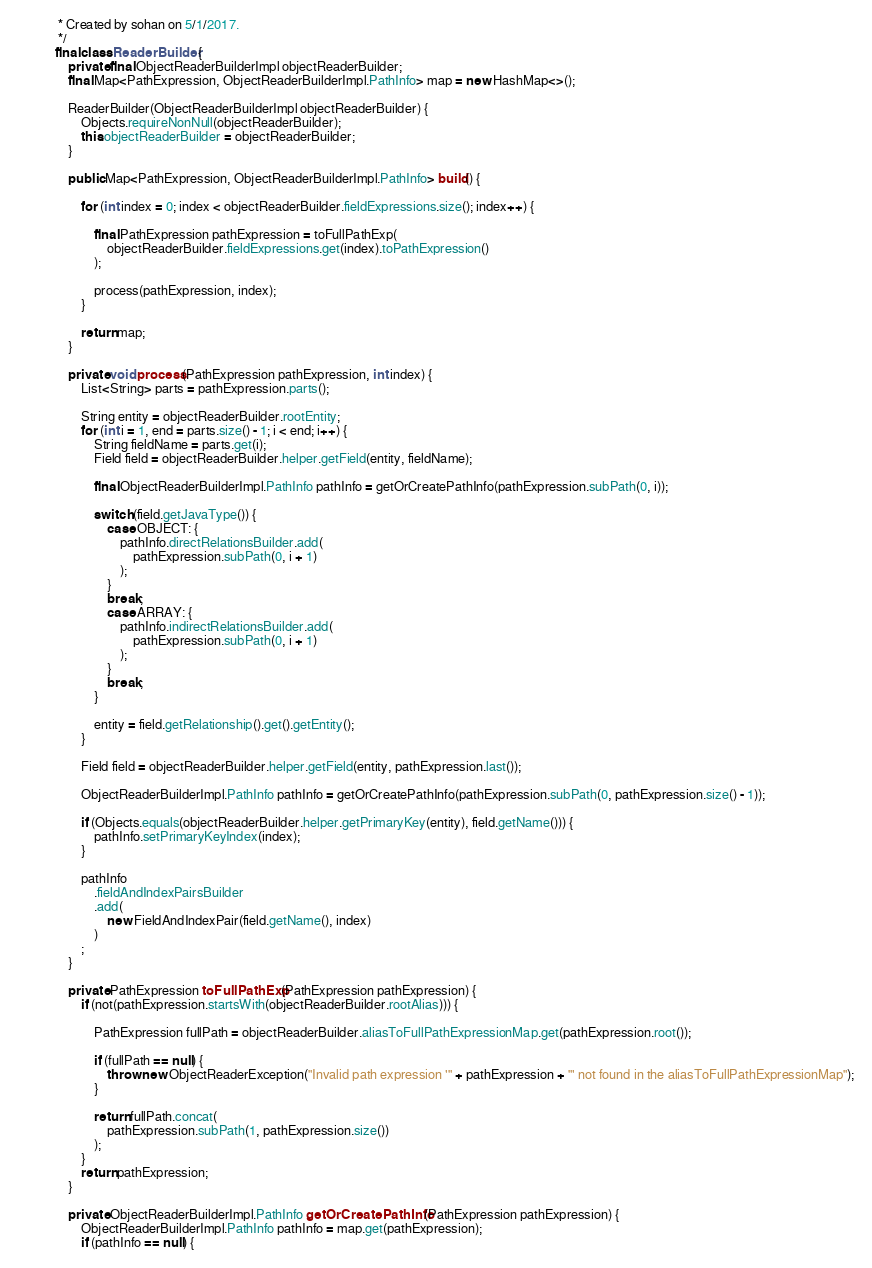<code> <loc_0><loc_0><loc_500><loc_500><_Java_> * Created by sohan on 5/1/2017.
 */
final class ReaderBuilder {
    private final ObjectReaderBuilderImpl objectReaderBuilder;
    final Map<PathExpression, ObjectReaderBuilderImpl.PathInfo> map = new HashMap<>();

    ReaderBuilder(ObjectReaderBuilderImpl objectReaderBuilder) {
        Objects.requireNonNull(objectReaderBuilder);
        this.objectReaderBuilder = objectReaderBuilder;
    }

    public Map<PathExpression, ObjectReaderBuilderImpl.PathInfo> build() {

        for (int index = 0; index < objectReaderBuilder.fieldExpressions.size(); index++) {

            final PathExpression pathExpression = toFullPathExp(
                objectReaderBuilder.fieldExpressions.get(index).toPathExpression()
            );

            process(pathExpression, index);
        }

        return map;
    }

    private void process(PathExpression pathExpression, int index) {
        List<String> parts = pathExpression.parts();

        String entity = objectReaderBuilder.rootEntity;
        for (int i = 1, end = parts.size() - 1; i < end; i++) {
            String fieldName = parts.get(i);
            Field field = objectReaderBuilder.helper.getField(entity, fieldName);

            final ObjectReaderBuilderImpl.PathInfo pathInfo = getOrCreatePathInfo(pathExpression.subPath(0, i));

            switch (field.getJavaType()) {
                case OBJECT: {
                    pathInfo.directRelationsBuilder.add(
                        pathExpression.subPath(0, i + 1)
                    );
                }
                break;
                case ARRAY: {
                    pathInfo.indirectRelationsBuilder.add(
                        pathExpression.subPath(0, i + 1)
                    );
                }
                break;
            }

            entity = field.getRelationship().get().getEntity();
        }

        Field field = objectReaderBuilder.helper.getField(entity, pathExpression.last());

        ObjectReaderBuilderImpl.PathInfo pathInfo = getOrCreatePathInfo(pathExpression.subPath(0, pathExpression.size() - 1));

        if (Objects.equals(objectReaderBuilder.helper.getPrimaryKey(entity), field.getName())) {
            pathInfo.setPrimaryKeyIndex(index);
        }

        pathInfo
            .fieldAndIndexPairsBuilder
            .add(
                new FieldAndIndexPair(field.getName(), index)
            )
        ;
    }

    private PathExpression toFullPathExp(PathExpression pathExpression) {
        if (not(pathExpression.startsWith(objectReaderBuilder.rootAlias))) {

            PathExpression fullPath = objectReaderBuilder.aliasToFullPathExpressionMap.get(pathExpression.root());

            if (fullPath == null) {
                throw new ObjectReaderException("Invalid path expression '" + pathExpression + "' not found in the aliasToFullPathExpressionMap");
            }

            return fullPath.concat(
                pathExpression.subPath(1, pathExpression.size())
            );
        }
        return pathExpression;
    }

    private ObjectReaderBuilderImpl.PathInfo getOrCreatePathInfo(PathExpression pathExpression) {
        ObjectReaderBuilderImpl.PathInfo pathInfo = map.get(pathExpression);
        if (pathInfo == null) {</code> 